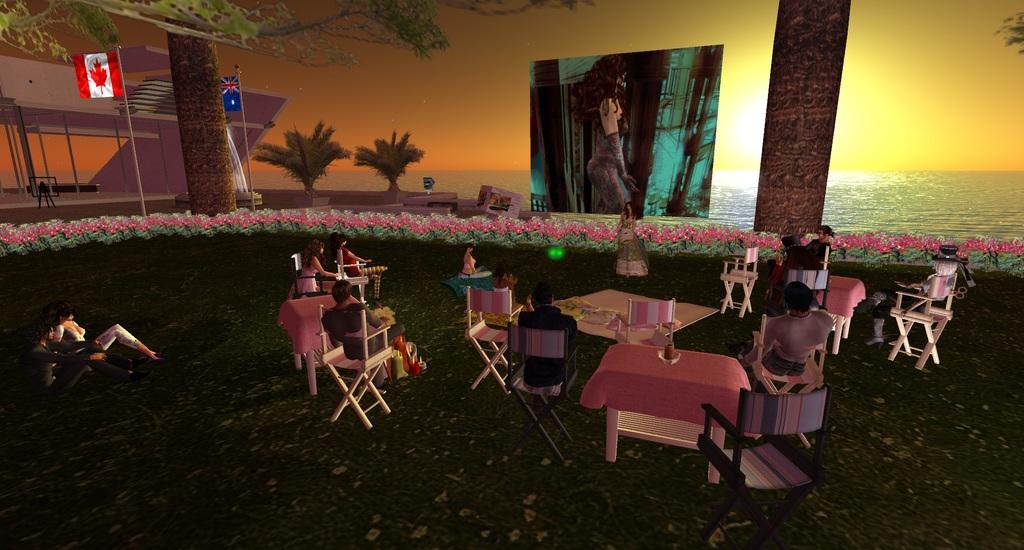What type of image is being described? The image is animated. What are the people in the image doing? There is a group of people sitting on chairs in the image. What is in front of the people? There is a screen in front of the people. What natural elements can be seen in the image? Trees, water, and the sky are visible in the image. What year is depicted in the image? The image does not depict a specific year; it is an animated scene. Can you see the people's tongues in the image? There is no indication of the people's tongues being visible in the image. 